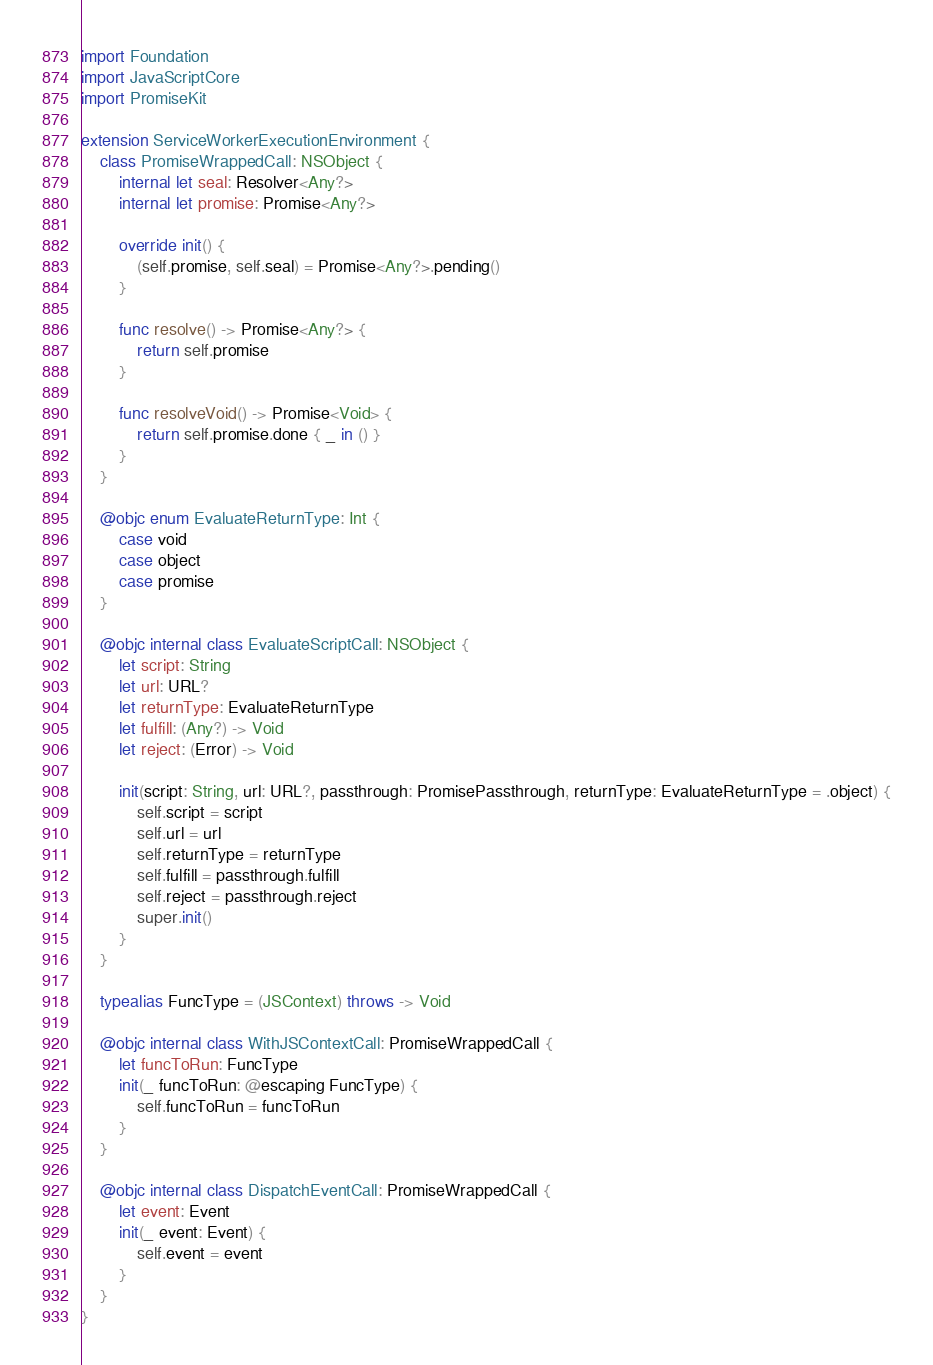<code> <loc_0><loc_0><loc_500><loc_500><_Swift_>import Foundation
import JavaScriptCore
import PromiseKit

extension ServiceWorkerExecutionEnvironment {
    class PromiseWrappedCall: NSObject {
        internal let seal: Resolver<Any?>
        internal let promise: Promise<Any?>

        override init() {
            (self.promise, self.seal) = Promise<Any?>.pending()
        }

        func resolve() -> Promise<Any?> {
            return self.promise
        }

        func resolveVoid() -> Promise<Void> {
            return self.promise.done { _ in () }
        }
    }

    @objc enum EvaluateReturnType: Int {
        case void
        case object
        case promise
    }

    @objc internal class EvaluateScriptCall: NSObject {
        let script: String
        let url: URL?
        let returnType: EvaluateReturnType
        let fulfill: (Any?) -> Void
        let reject: (Error) -> Void

        init(script: String, url: URL?, passthrough: PromisePassthrough, returnType: EvaluateReturnType = .object) {
            self.script = script
            self.url = url
            self.returnType = returnType
            self.fulfill = passthrough.fulfill
            self.reject = passthrough.reject
            super.init()
        }
    }

    typealias FuncType = (JSContext) throws -> Void

    @objc internal class WithJSContextCall: PromiseWrappedCall {
        let funcToRun: FuncType
        init(_ funcToRun: @escaping FuncType) {
            self.funcToRun = funcToRun
        }
    }

    @objc internal class DispatchEventCall: PromiseWrappedCall {
        let event: Event
        init(_ event: Event) {
            self.event = event
        }
    }
}
</code> 